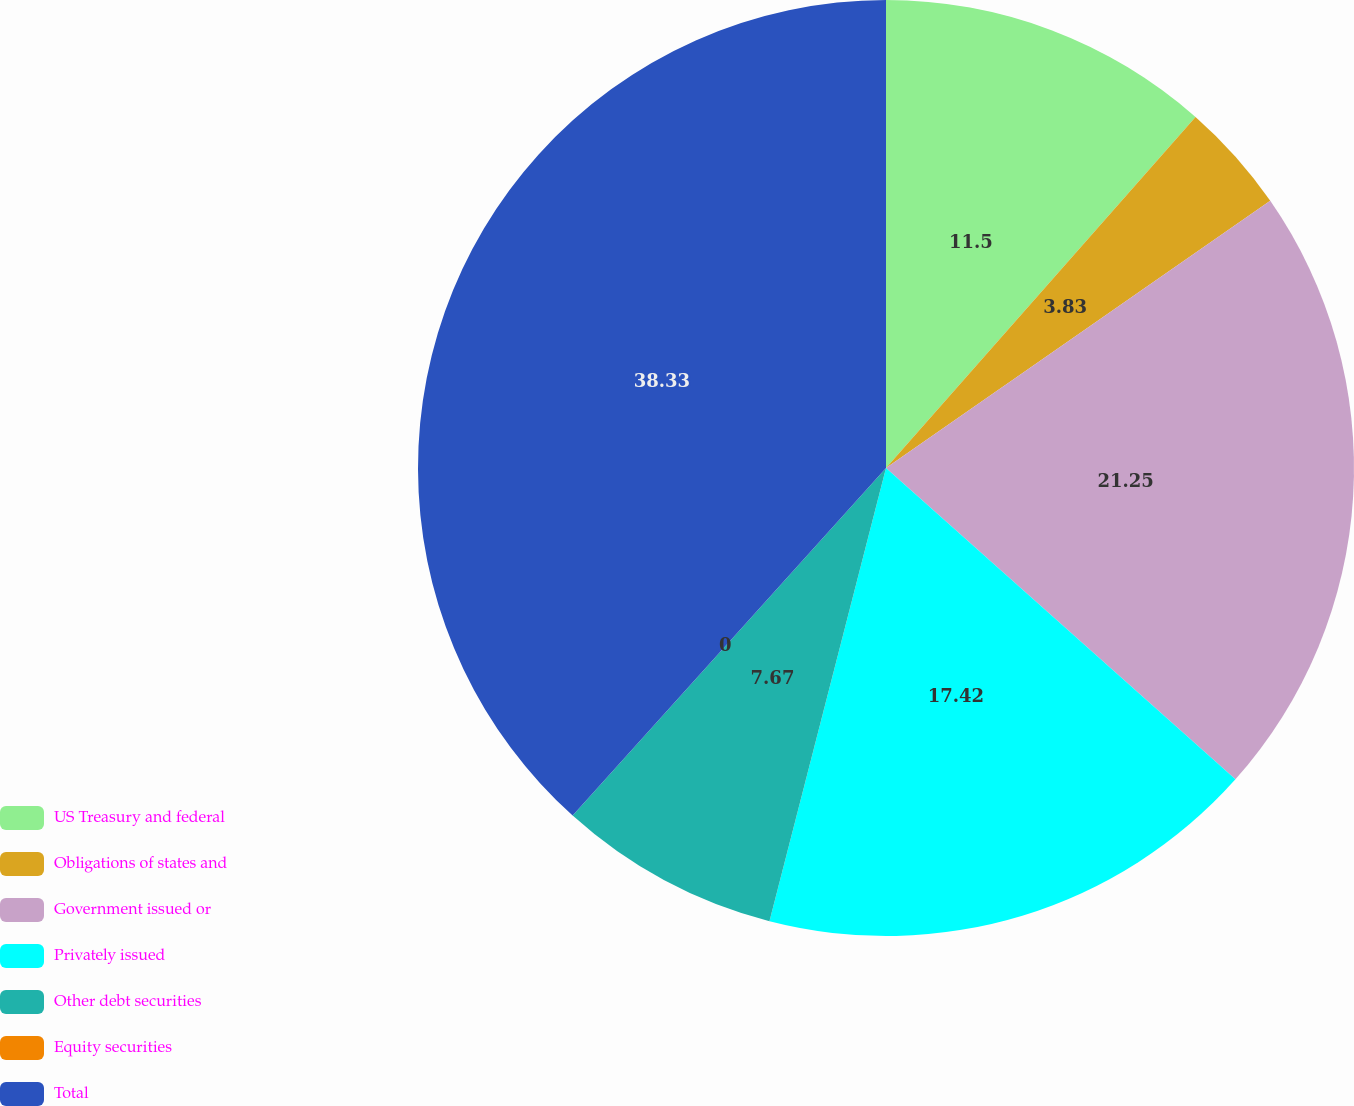Convert chart. <chart><loc_0><loc_0><loc_500><loc_500><pie_chart><fcel>US Treasury and federal<fcel>Obligations of states and<fcel>Government issued or<fcel>Privately issued<fcel>Other debt securities<fcel>Equity securities<fcel>Total<nl><fcel>11.5%<fcel>3.83%<fcel>21.25%<fcel>17.42%<fcel>7.67%<fcel>0.0%<fcel>38.32%<nl></chart> 